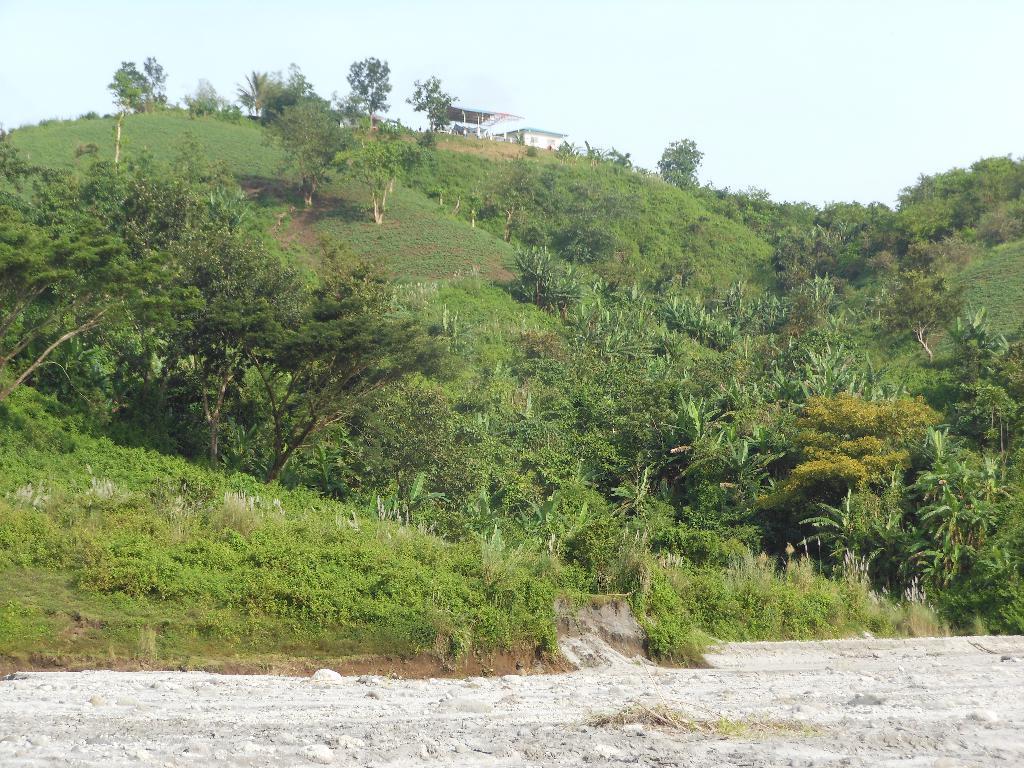Could you give a brief overview of what you see in this image? In this picture I can observe some trees and plants on the hill. It is looking like a house on the top of the hill. In the background there is a sky. 